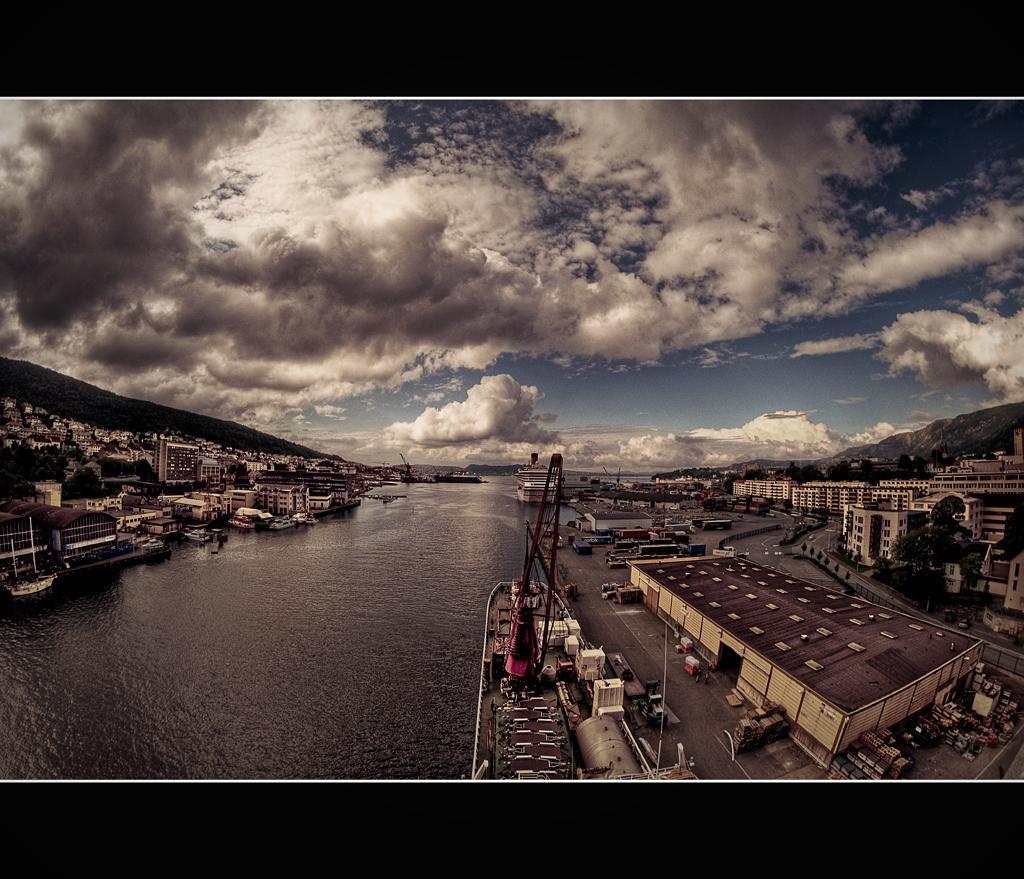Can you describe this image briefly? This picture is an edited picture. In this image there are buildings, trees and poles and there are vehicles on the road. There are boats on the water. At the top there is sky and there are clouds. At the bottom there is a water and there is a road. 